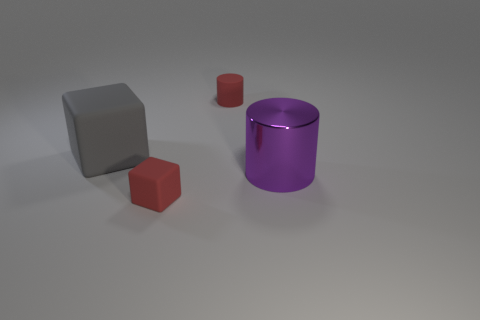Add 1 shiny cylinders. How many objects exist? 5 Subtract all gray blocks. Subtract all cubes. How many objects are left? 1 Add 4 metallic objects. How many metallic objects are left? 5 Add 2 tiny things. How many tiny things exist? 4 Subtract 0 green spheres. How many objects are left? 4 Subtract all purple cylinders. Subtract all red blocks. How many cylinders are left? 1 